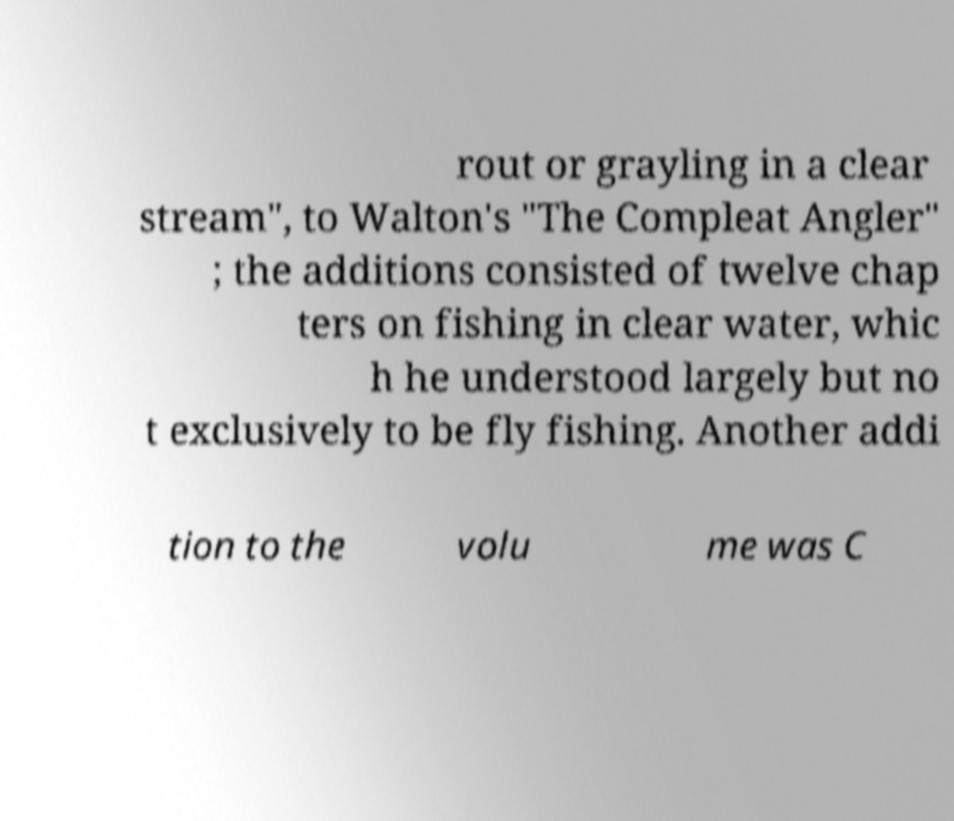Could you extract and type out the text from this image? rout or grayling in a clear stream", to Walton's "The Compleat Angler" ; the additions consisted of twelve chap ters on fishing in clear water, whic h he understood largely but no t exclusively to be fly fishing. Another addi tion to the volu me was C 